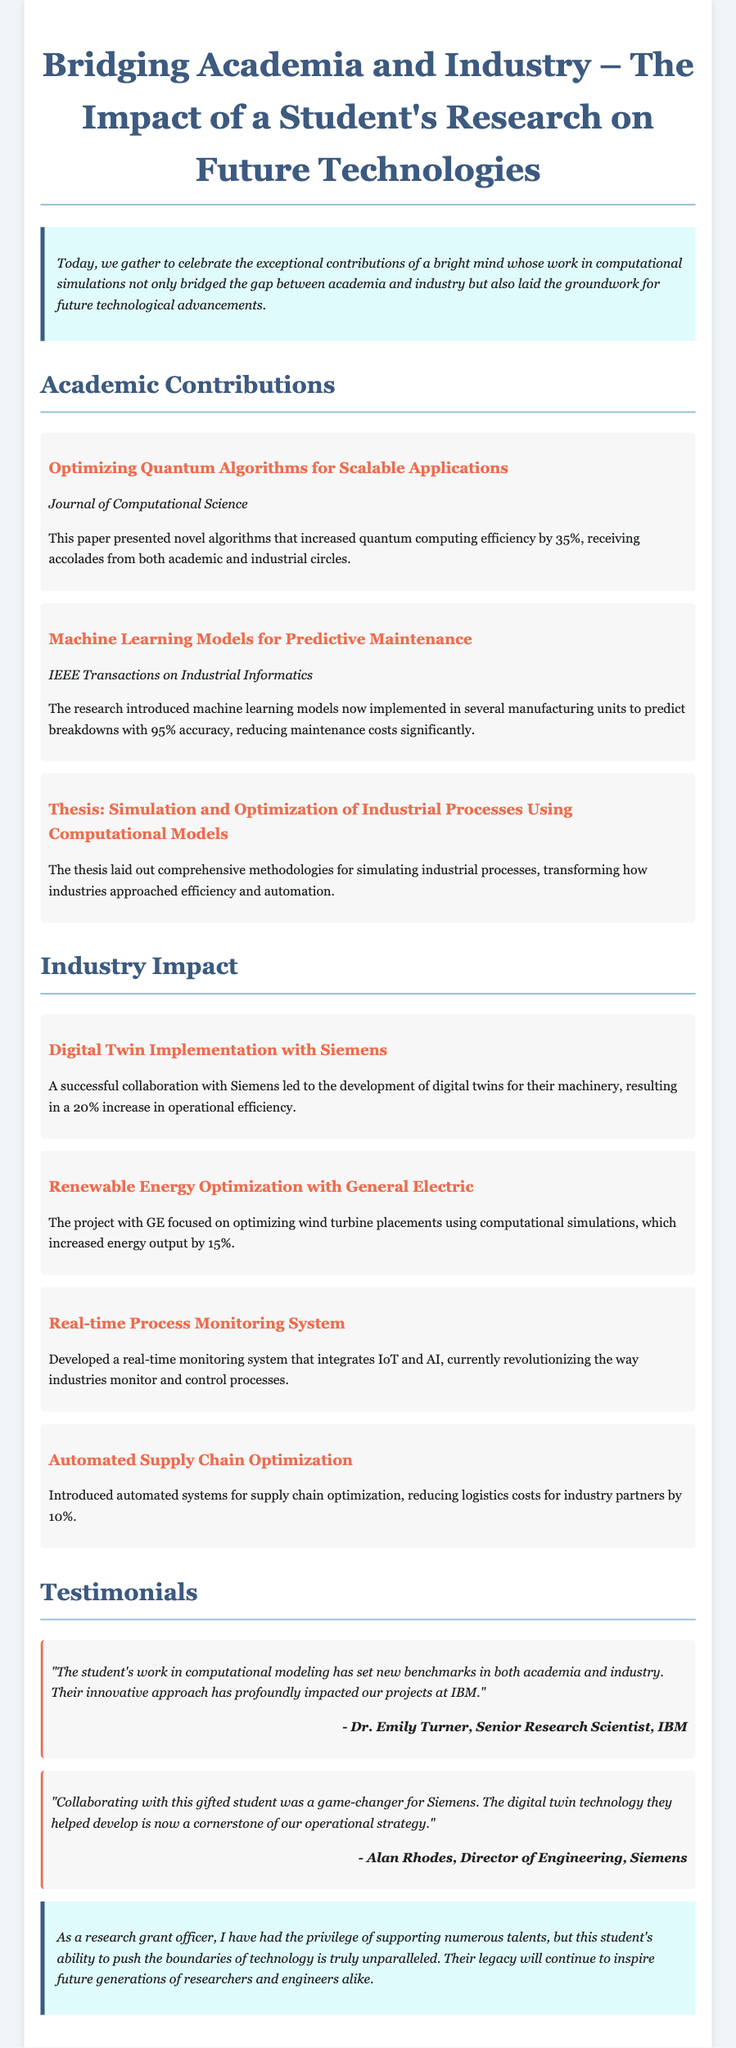what is the title of the first publication? The title of the first publication is listed under Academic Contributions, which focuses on optimizing quantum algorithms.
Answer: Optimizing Quantum Algorithms for Scalable Applications how much did the research increase quantum computing efficiency? The document states that the research increased quantum computing efficiency by a specific percentage mentioned in the first publication.
Answer: 35% which company collaborated with the student on digital twins? The collaboration involving digital twins is mentioned in the Industry Impact section, specifically named as one of the high-profile companies.
Answer: Siemens what is the percentage increase in energy output from the project with General Electric? The document provides a statistic related to energy output growth in the project with GE.
Answer: 15% who is the author of the testimonial from IBM? The testimonial from IBM includes the name of a specific individual who authored the endorsement statement.
Answer: Dr. Emily Turner what technology is now a cornerstone of Siemens' operational strategy? The document highlights a specific technology developed through the collaboration with Siemens that is now essential to their operations.
Answer: digital twin technology how significant was the reduction in maintenance costs achieved through predictive maintenance models? The impact on maintenance costs is described as a significant achievement in the relevant publication discussed in the document.
Answer: 95% accuracy how much did logistics costs reduce for industry partners due to the automated systems? The document quantifies the reduction in logistics costs brought about by the student's automation work in supply chains.
Answer: 10% 